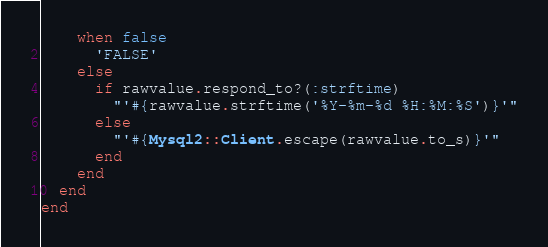Convert code to text. <code><loc_0><loc_0><loc_500><loc_500><_Ruby_>    when false
      'FALSE'
    else
      if rawvalue.respond_to?(:strftime)
        "'#{rawvalue.strftime('%Y-%m-%d %H:%M:%S')}'"
      else
        "'#{Mysql2::Client.escape(rawvalue.to_s)}'"
      end
    end
  end
end
</code> 